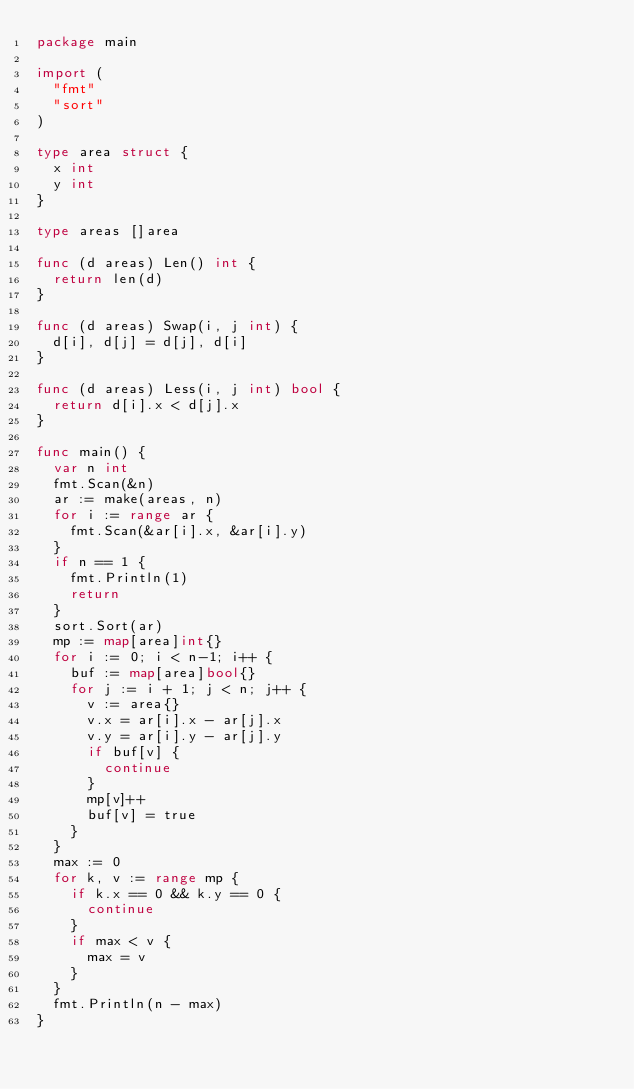<code> <loc_0><loc_0><loc_500><loc_500><_Go_>package main

import (
	"fmt"
	"sort"
)

type area struct {
	x int
	y int
}

type areas []area

func (d areas) Len() int {
	return len(d)
}

func (d areas) Swap(i, j int) {
	d[i], d[j] = d[j], d[i]
}

func (d areas) Less(i, j int) bool {
	return d[i].x < d[j].x
}

func main() {
	var n int
	fmt.Scan(&n)
	ar := make(areas, n)
	for i := range ar {
		fmt.Scan(&ar[i].x, &ar[i].y)
	}
	if n == 1 {
		fmt.Println(1)
		return
	}
	sort.Sort(ar)
	mp := map[area]int{}
	for i := 0; i < n-1; i++ {
		buf := map[area]bool{}
		for j := i + 1; j < n; j++ {
			v := area{}
			v.x = ar[i].x - ar[j].x
			v.y = ar[i].y - ar[j].y
			if buf[v] {
				continue
			}
			mp[v]++
			buf[v] = true
		}
	}
	max := 0
	for k, v := range mp {
		if k.x == 0 && k.y == 0 {
			continue
		}
		if max < v {
			max = v
		}
	}
	fmt.Println(n - max)
}
</code> 